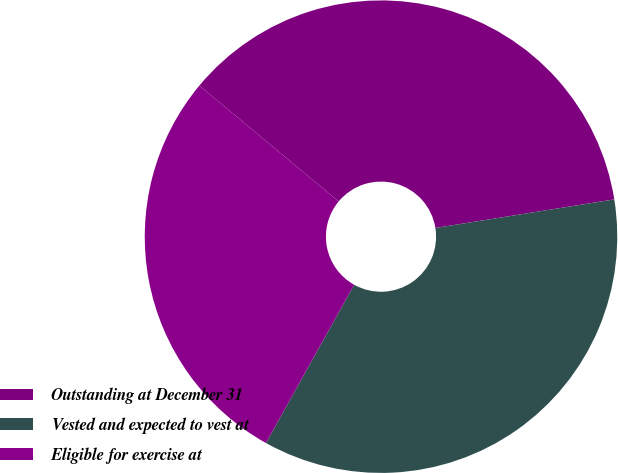<chart> <loc_0><loc_0><loc_500><loc_500><pie_chart><fcel>Outstanding at December 31<fcel>Vested and expected to vest at<fcel>Eligible for exercise at<nl><fcel>36.44%<fcel>35.62%<fcel>27.95%<nl></chart> 